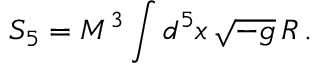Convert formula to latex. <formula><loc_0><loc_0><loc_500><loc_500>S _ { 5 } = M ^ { 3 } \int d ^ { 5 } x \, \sqrt { - g } \, R \, .</formula> 